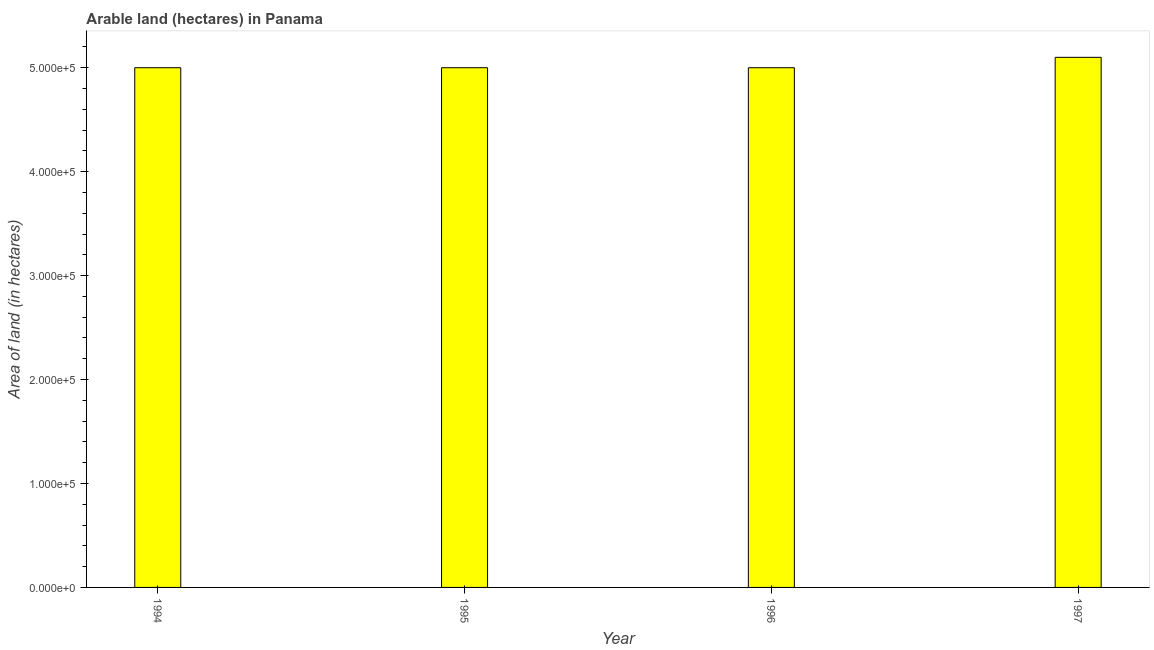Does the graph contain grids?
Give a very brief answer. No. What is the title of the graph?
Keep it short and to the point. Arable land (hectares) in Panama. What is the label or title of the Y-axis?
Offer a very short reply. Area of land (in hectares). What is the area of land in 1997?
Keep it short and to the point. 5.10e+05. Across all years, what is the maximum area of land?
Offer a terse response. 5.10e+05. In which year was the area of land minimum?
Offer a terse response. 1994. What is the sum of the area of land?
Offer a terse response. 2.01e+06. What is the average area of land per year?
Ensure brevity in your answer.  5.02e+05. In how many years, is the area of land greater than 60000 hectares?
Keep it short and to the point. 4. Is the difference between the area of land in 1994 and 1997 greater than the difference between any two years?
Make the answer very short. Yes. What is the difference between the highest and the second highest area of land?
Offer a very short reply. 10000. Is the sum of the area of land in 1994 and 1997 greater than the maximum area of land across all years?
Keep it short and to the point. Yes. In how many years, is the area of land greater than the average area of land taken over all years?
Your response must be concise. 1. How many bars are there?
Your response must be concise. 4. Are all the bars in the graph horizontal?
Make the answer very short. No. How many years are there in the graph?
Ensure brevity in your answer.  4. Are the values on the major ticks of Y-axis written in scientific E-notation?
Give a very brief answer. Yes. What is the Area of land (in hectares) in 1997?
Keep it short and to the point. 5.10e+05. What is the difference between the Area of land (in hectares) in 1994 and 1996?
Provide a short and direct response. 0. What is the difference between the Area of land (in hectares) in 1994 and 1997?
Your response must be concise. -10000. What is the difference between the Area of land (in hectares) in 1995 and 1996?
Give a very brief answer. 0. What is the difference between the Area of land (in hectares) in 1995 and 1997?
Give a very brief answer. -10000. What is the difference between the Area of land (in hectares) in 1996 and 1997?
Offer a very short reply. -10000. What is the ratio of the Area of land (in hectares) in 1994 to that in 1996?
Your response must be concise. 1. What is the ratio of the Area of land (in hectares) in 1994 to that in 1997?
Give a very brief answer. 0.98. 